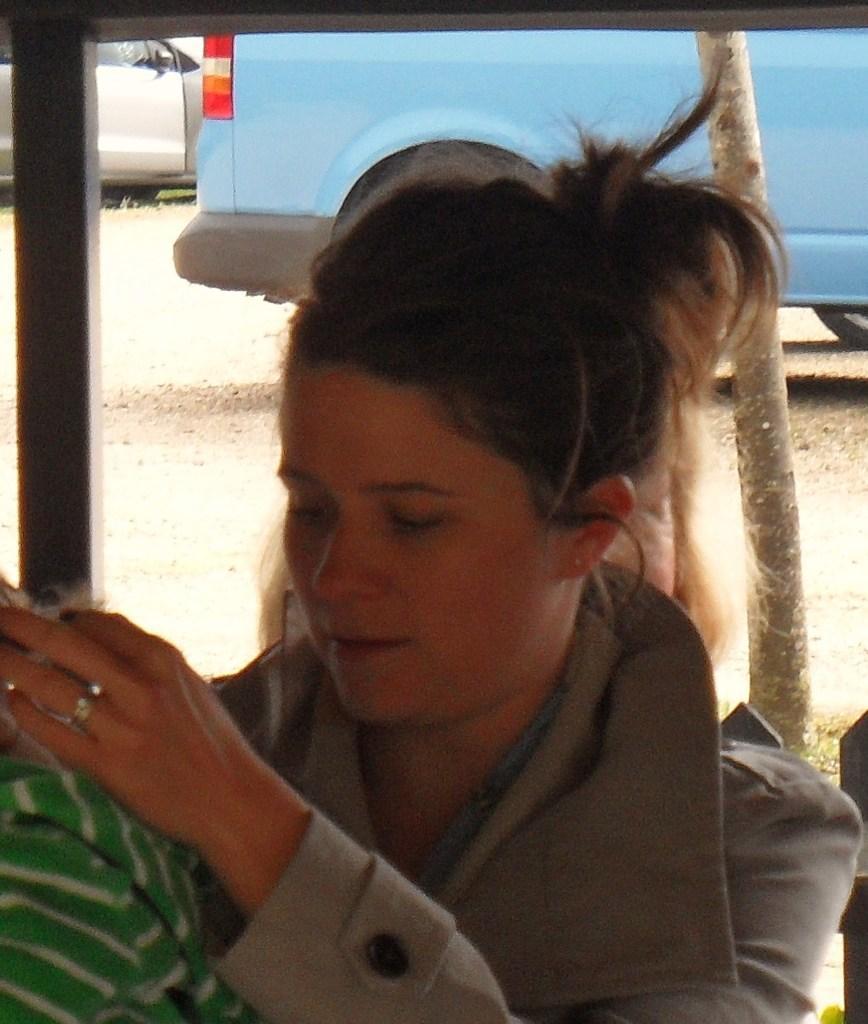Could you give a brief overview of what you see in this image? In this picture there is a woman who is wearing jacket and finger ring. She is sitting near to the girl who is wearing green hoodie. At the back I can see the bus and car which is parked near to the bamboo. In the top left corner there is a black fencing. In the bottom right corner there is a chair. 